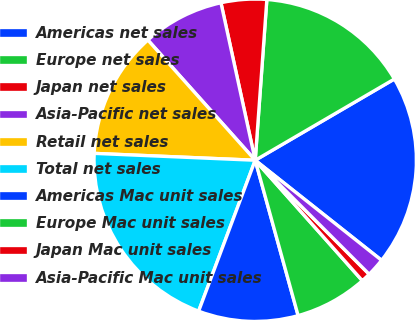Convert chart. <chart><loc_0><loc_0><loc_500><loc_500><pie_chart><fcel>Americas net sales<fcel>Europe net sales<fcel>Japan net sales<fcel>Asia-Pacific net sales<fcel>Retail net sales<fcel>Total net sales<fcel>Americas Mac unit sales<fcel>Europe Mac unit sales<fcel>Japan Mac unit sales<fcel>Asia-Pacific Mac unit sales<nl><fcel>19.07%<fcel>15.44%<fcel>4.56%<fcel>8.19%<fcel>12.72%<fcel>19.97%<fcel>10.0%<fcel>7.28%<fcel>0.93%<fcel>1.84%<nl></chart> 